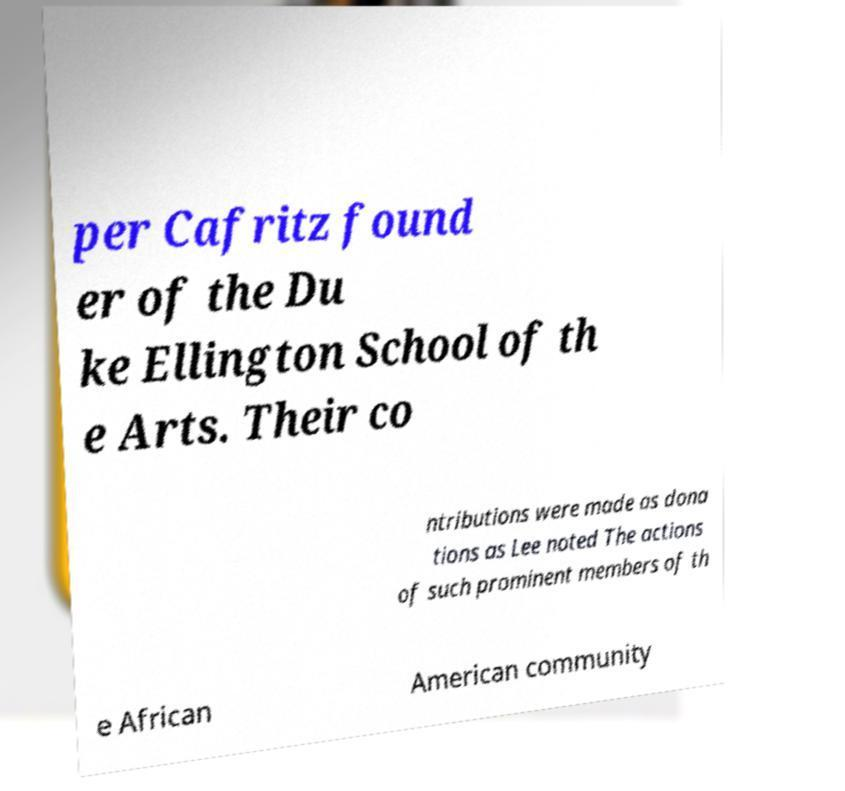What messages or text are displayed in this image? I need them in a readable, typed format. per Cafritz found er of the Du ke Ellington School of th e Arts. Their co ntributions were made as dona tions as Lee noted The actions of such prominent members of th e African American community 